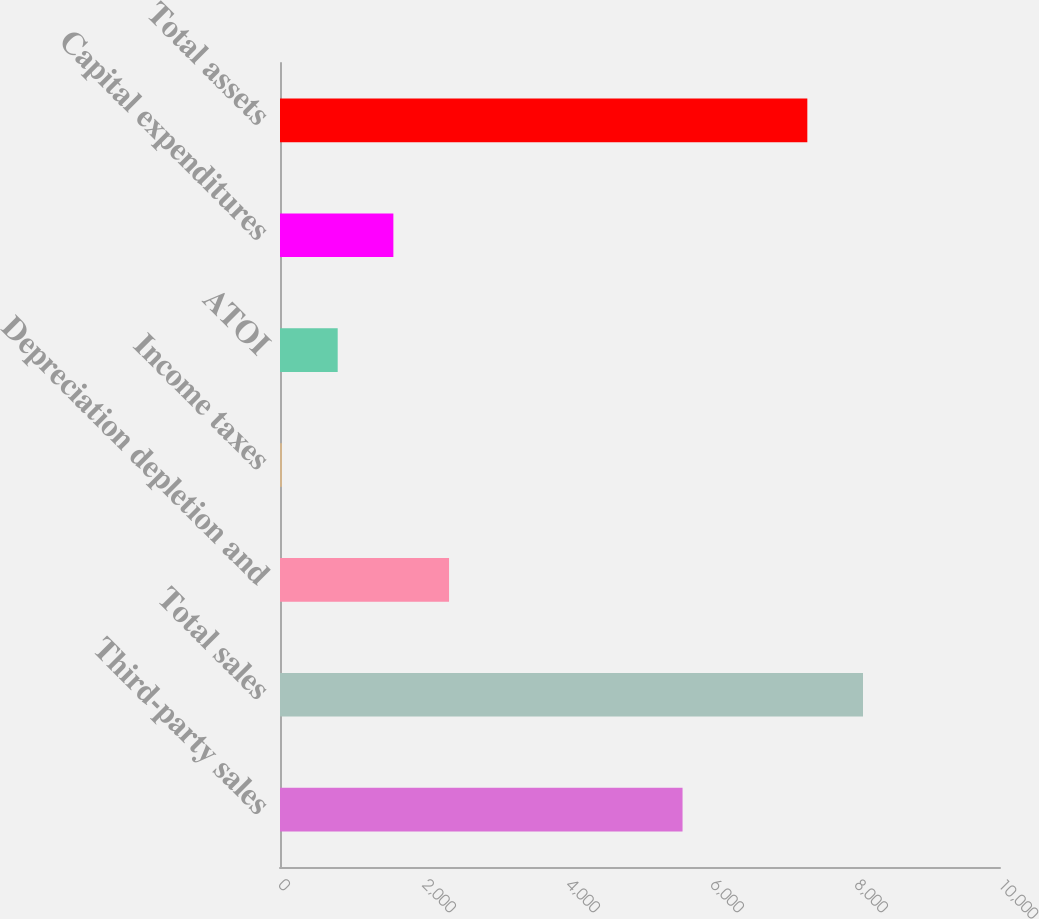Convert chart. <chart><loc_0><loc_0><loc_500><loc_500><bar_chart><fcel>Third-party sales<fcel>Total sales<fcel>Depreciation depletion and<fcel>Income taxes<fcel>ATOI<fcel>Capital expenditures<fcel>Total assets<nl><fcel>5591<fcel>8097.3<fcel>2347.9<fcel>28<fcel>801.3<fcel>1574.6<fcel>7324<nl></chart> 